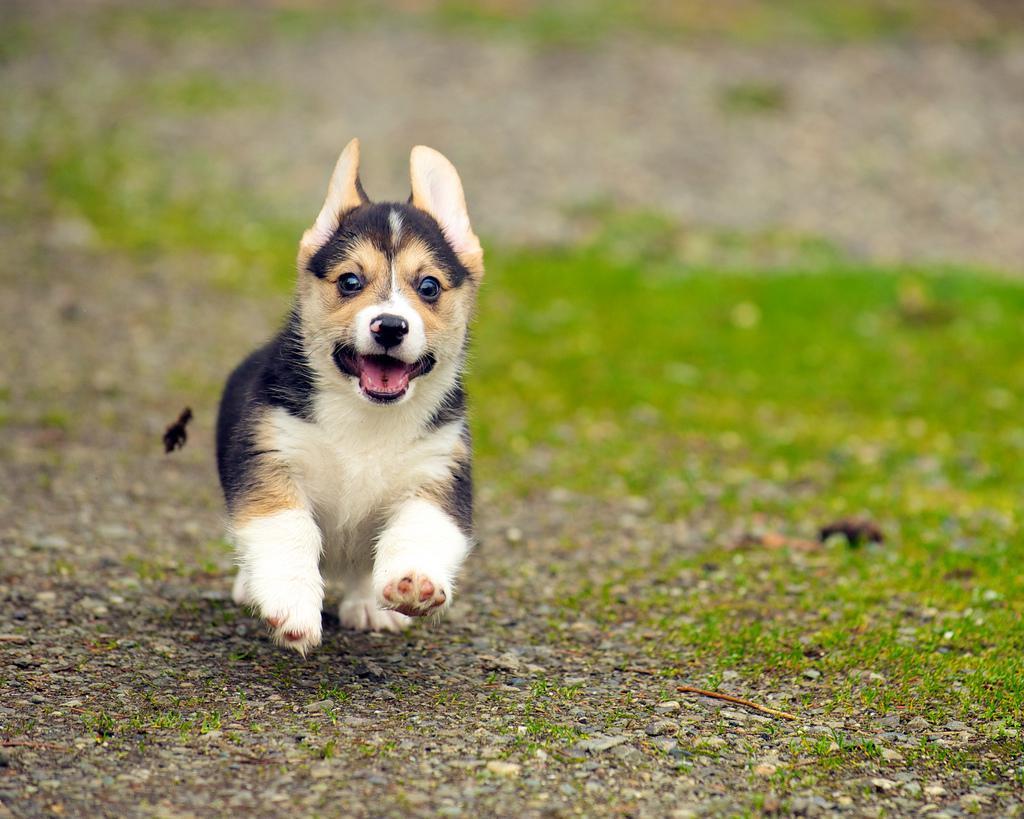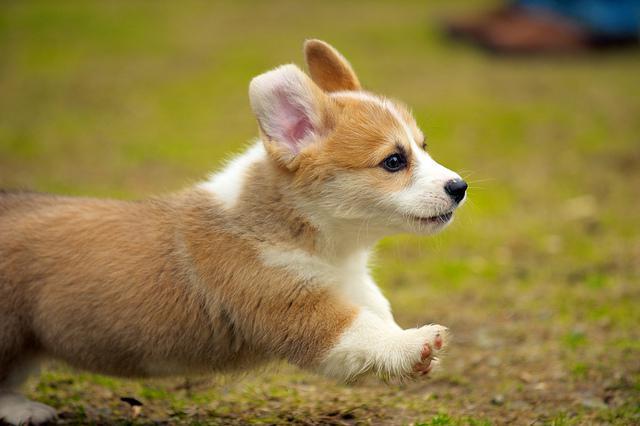The first image is the image on the left, the second image is the image on the right. For the images shown, is this caption "At least one puppy has both front paws off the ground." true? Answer yes or no. Yes. The first image is the image on the left, the second image is the image on the right. For the images displayed, is the sentence "One image shows three corgi dogs running across the grass, with one dog in the lead, and a blue tent canopy behind them." factually correct? Answer yes or no. No. 